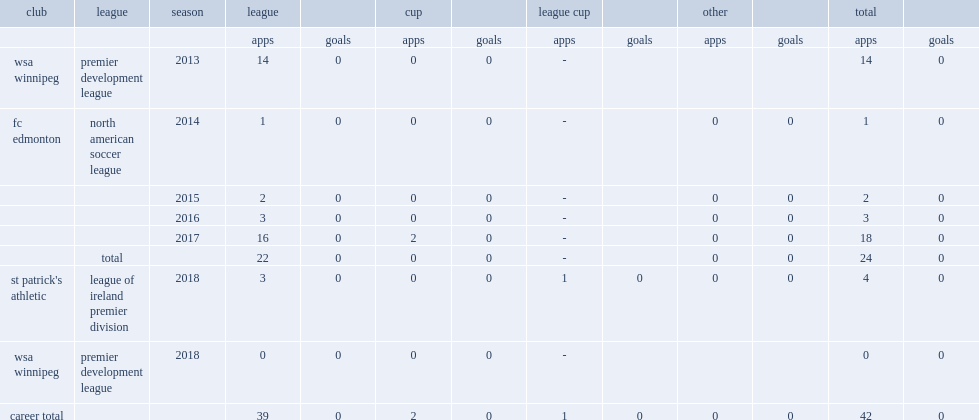Which club did farago play for in 2018? St patrick's athletic. 